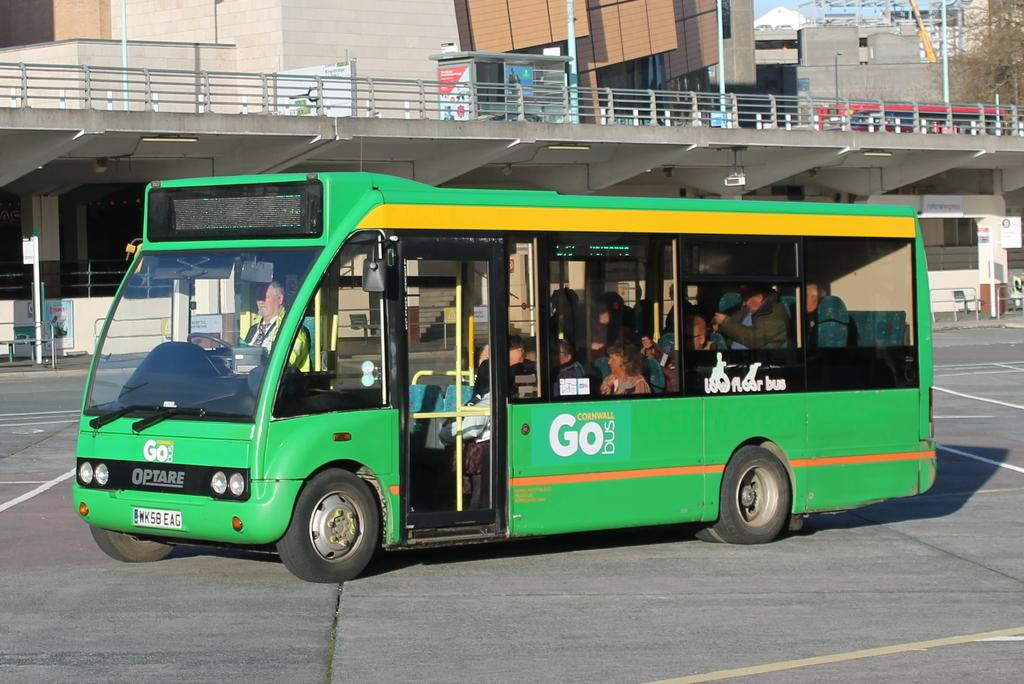<image>
Summarize the visual content of the image. Many people ride a green "Go" bus through a parking lot. 